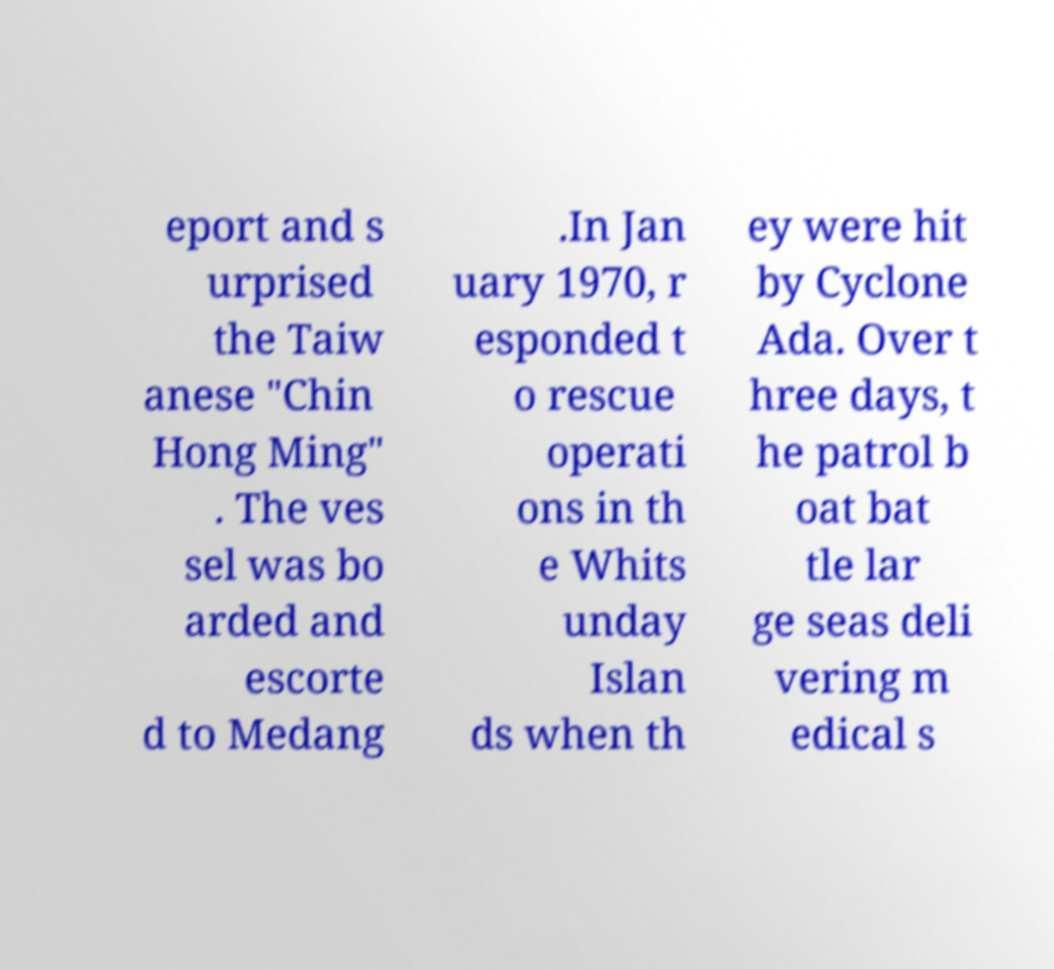Could you assist in decoding the text presented in this image and type it out clearly? eport and s urprised the Taiw anese "Chin Hong Ming" . The ves sel was bo arded and escorte d to Medang .In Jan uary 1970, r esponded t o rescue operati ons in th e Whits unday Islan ds when th ey were hit by Cyclone Ada. Over t hree days, t he patrol b oat bat tle lar ge seas deli vering m edical s 